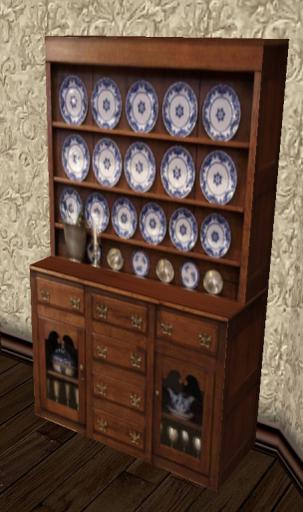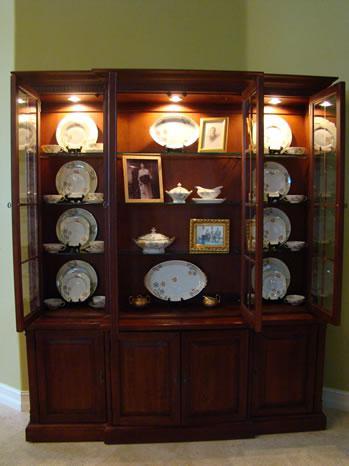The first image is the image on the left, the second image is the image on the right. Evaluate the accuracy of this statement regarding the images: "Blue and white patterned plates are displayed on the shelves of one china cabinet.". Is it true? Answer yes or no. Yes. The first image is the image on the left, the second image is the image on the right. For the images shown, is this caption "There are display items on top of at least one hutch" true? Answer yes or no. No. 